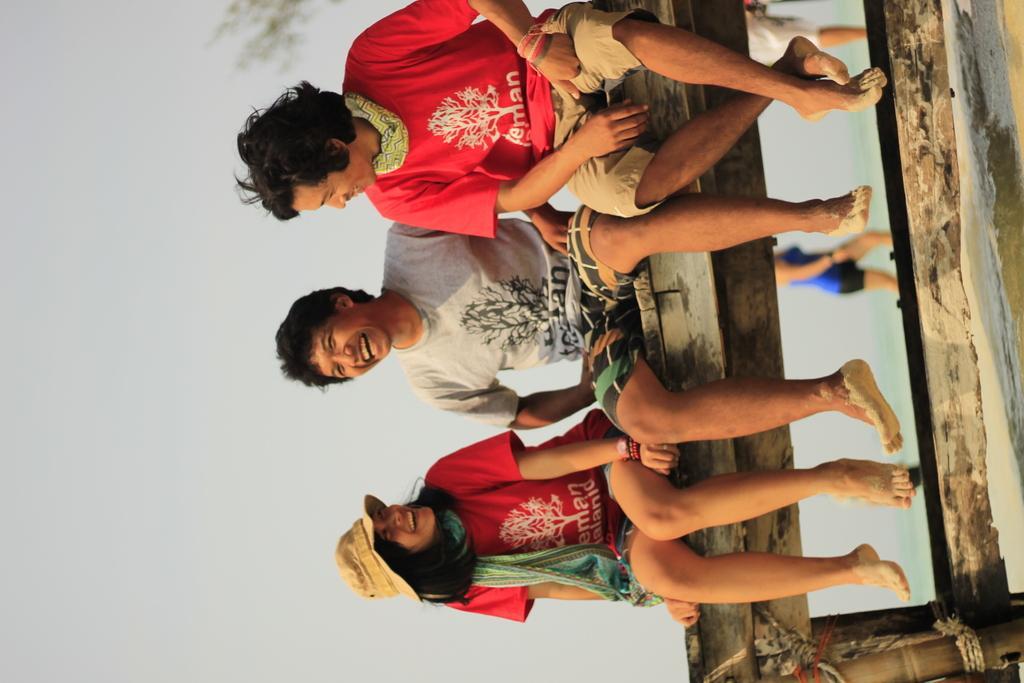In one or two sentences, can you explain what this image depicts? In this picture, we can see three people sitting on a wooden bench and behind the people there is a woman walking on the path and at the background there is a sky. 